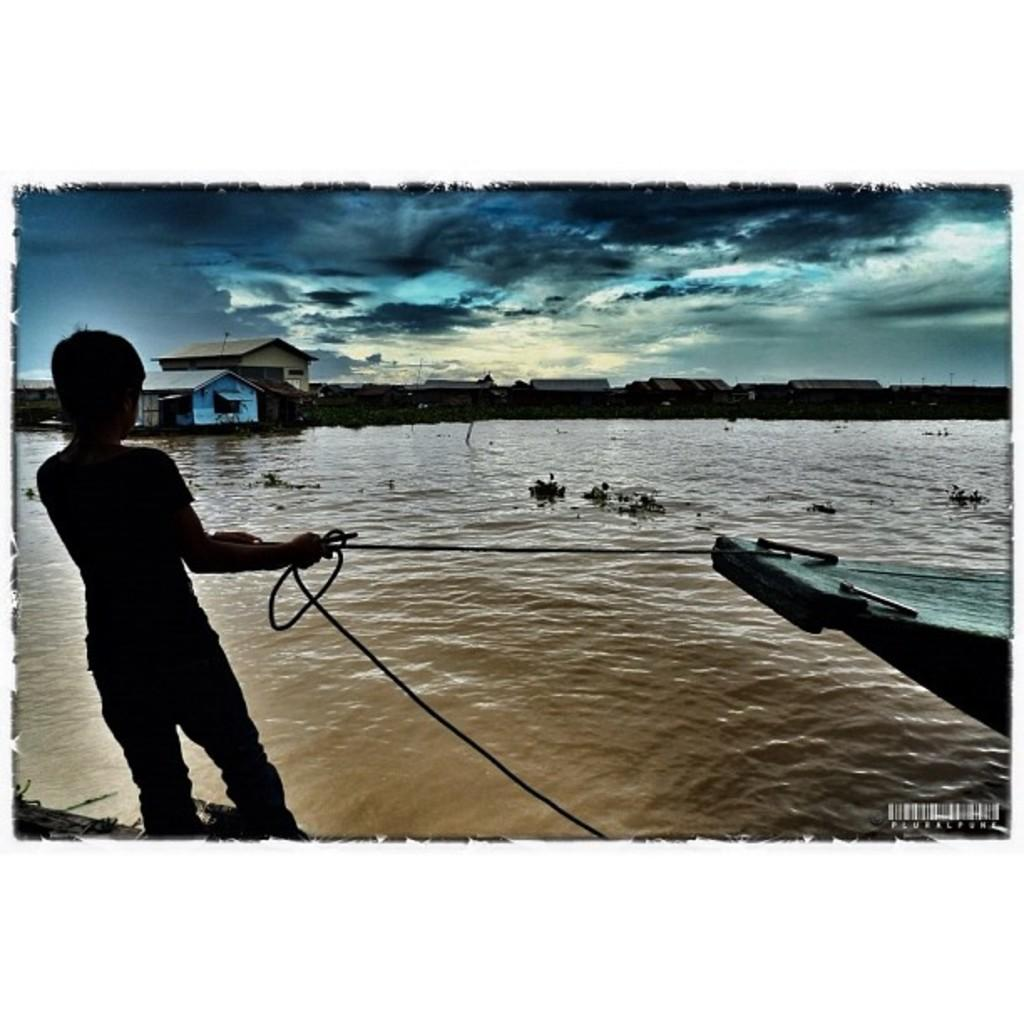What is present in the image that is related to water? There is water in the image. What can be seen floating on the water in the image? There is a boat in the image. Where is the person located in the image? The person is standing on the left side of the image. What type of structures can be seen in the background of the image? There are buildings in the background of the image. What is visible at the top of the image? The sky is visible at the top of the image. What can be observed in the sky? There are clouds in the sky. How many pets can be seen in the image? There are no pets present in the image. Is there a zoo visible in the background of the image? There is no zoo present in the image; only buildings and clouds can be seen in the background. 